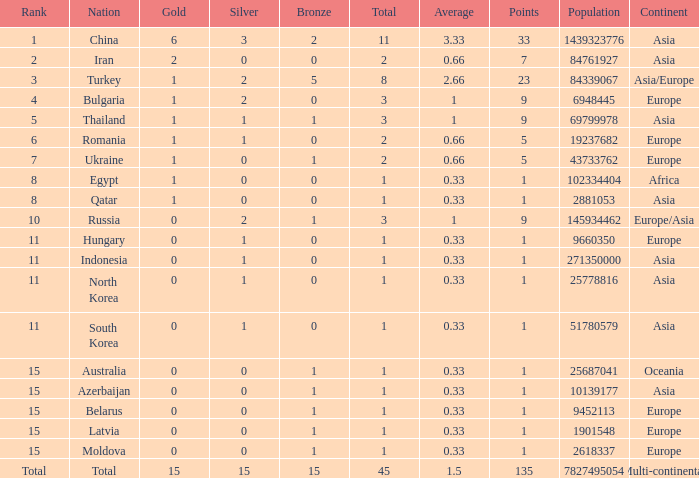What is the sum of the bronze medals of the nation with less than 0 silvers? None. 